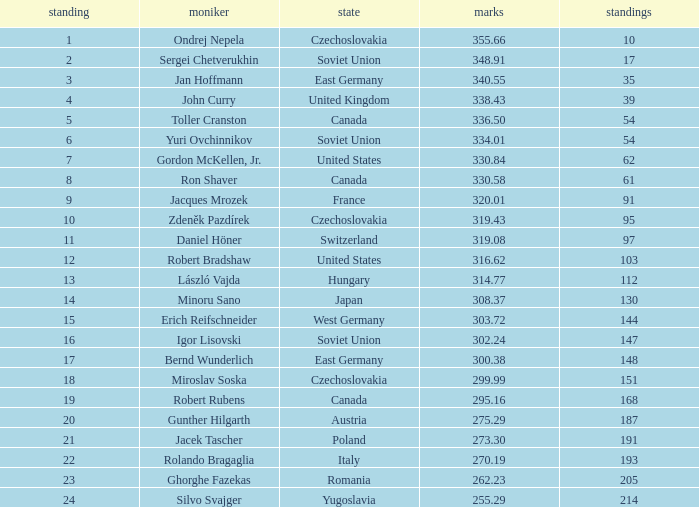How many Placings have Points smaller than 330.84, and a Name of silvo svajger? 1.0. 